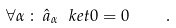<formula> <loc_0><loc_0><loc_500><loc_500>\forall \alpha \, \colon \, \hat { a } _ { \alpha } \ k e t { 0 } = 0 \quad .</formula> 